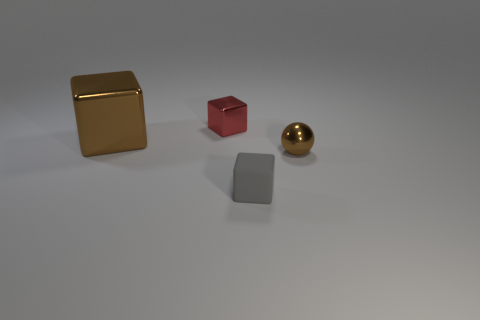Is the brown metallic cube the same size as the ball?
Keep it short and to the point. No. What is the size of the brown cube that is made of the same material as the sphere?
Provide a short and direct response. Large. What number of things are tiny gray rubber things or tiny shiny balls?
Your response must be concise. 2. There is a tiny metal sphere right of the gray block; what is its color?
Your answer should be compact. Brown. There is a brown metallic object that is the same shape as the gray thing; what is its size?
Your response must be concise. Large. What number of things are either objects that are in front of the big metal cube or shiny objects behind the sphere?
Keep it short and to the point. 4. What is the size of the metallic thing that is both on the right side of the large thing and to the left of the small gray matte thing?
Give a very brief answer. Small. There is a big brown object; does it have the same shape as the small metallic object to the left of the matte cube?
Provide a succinct answer. Yes. How many objects are cubes that are behind the small shiny sphere or small rubber blocks?
Your response must be concise. 3. Does the red block have the same material as the brown thing that is on the right side of the small metallic cube?
Give a very brief answer. Yes. 